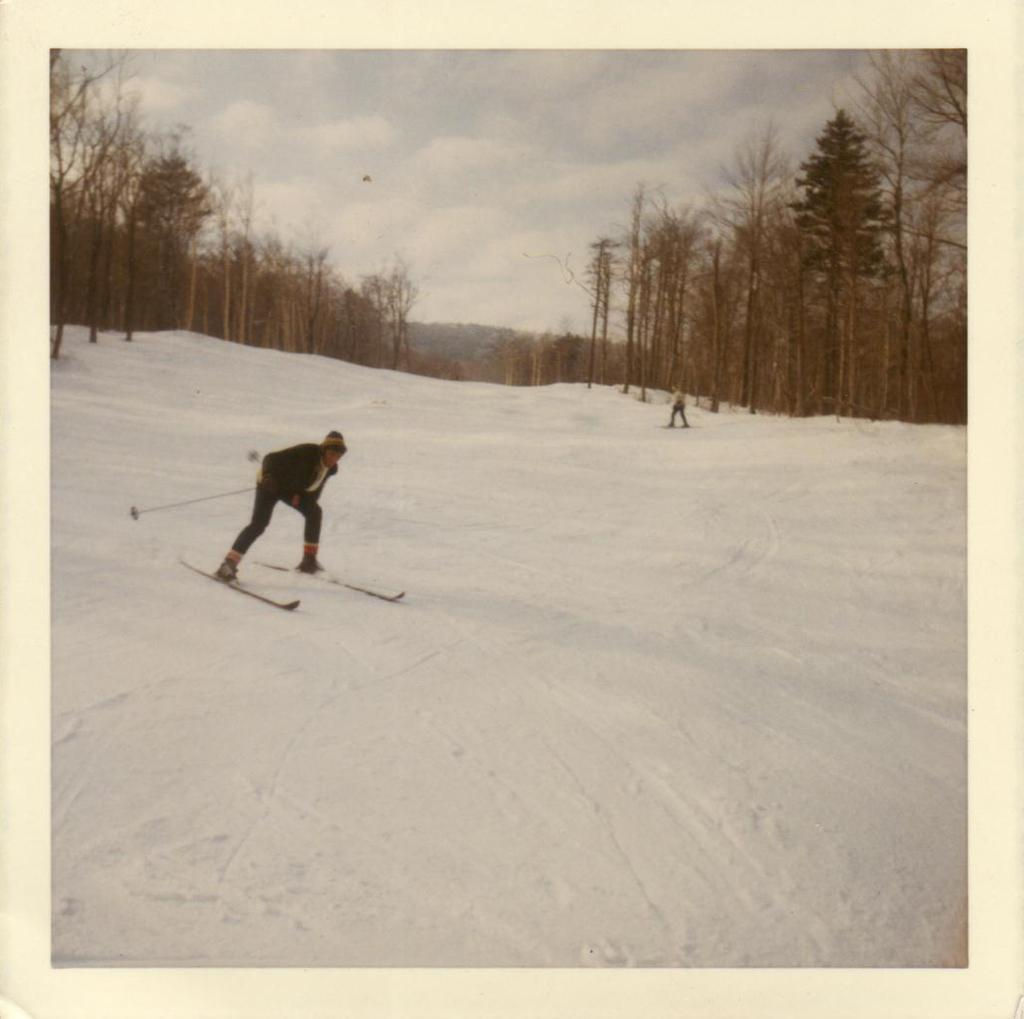What activity is the person in the image engaged in? The person is skiing in the image. What equipment is the person using for skiing? The person is using skis and holding a stick. Can you describe the background of the image? There is another person visible in the background, along with trees and the sky. What is the condition of the sky in the sky in the image? The sky is visible in the background of the image, and clouds are present. Reasoning: Let' Let's think step by step in order to produce the conversation. We start by identifying the main subject of the image, which is the person skiing. Then, we describe the equipment the person is using for skiing. Next, we expand the conversation to include details about the background of the image, such as the presence of another person, trees, and the sky. Finally, we mention the condition of the sky, which is cloudy. Absurd Question/Answer: What type of train can be seen in the image? There is no train present in the image; it features a person skiing. How many fingers does the person skiing have in the image? The number of fingers the person skiing has cannot be determined from the image. 